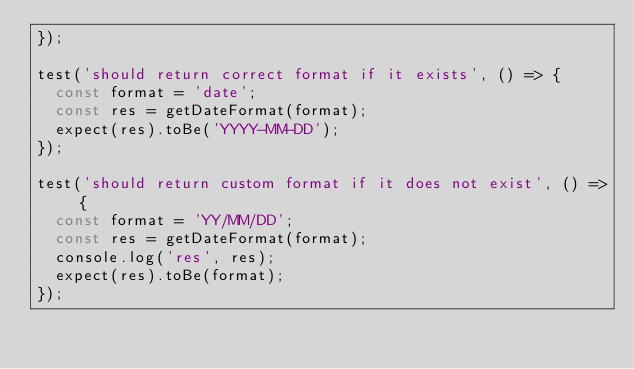<code> <loc_0><loc_0><loc_500><loc_500><_JavaScript_>});

test('should return correct format if it exists', () => {
	const format = 'date';
	const res = getDateFormat(format);
	expect(res).toBe('YYYY-MM-DD');
});

test('should return custom format if it does not exist', () => {
	const format = 'YY/MM/DD';
	const res = getDateFormat(format);
	console.log('res', res);
	expect(res).toBe(format);
});
</code> 